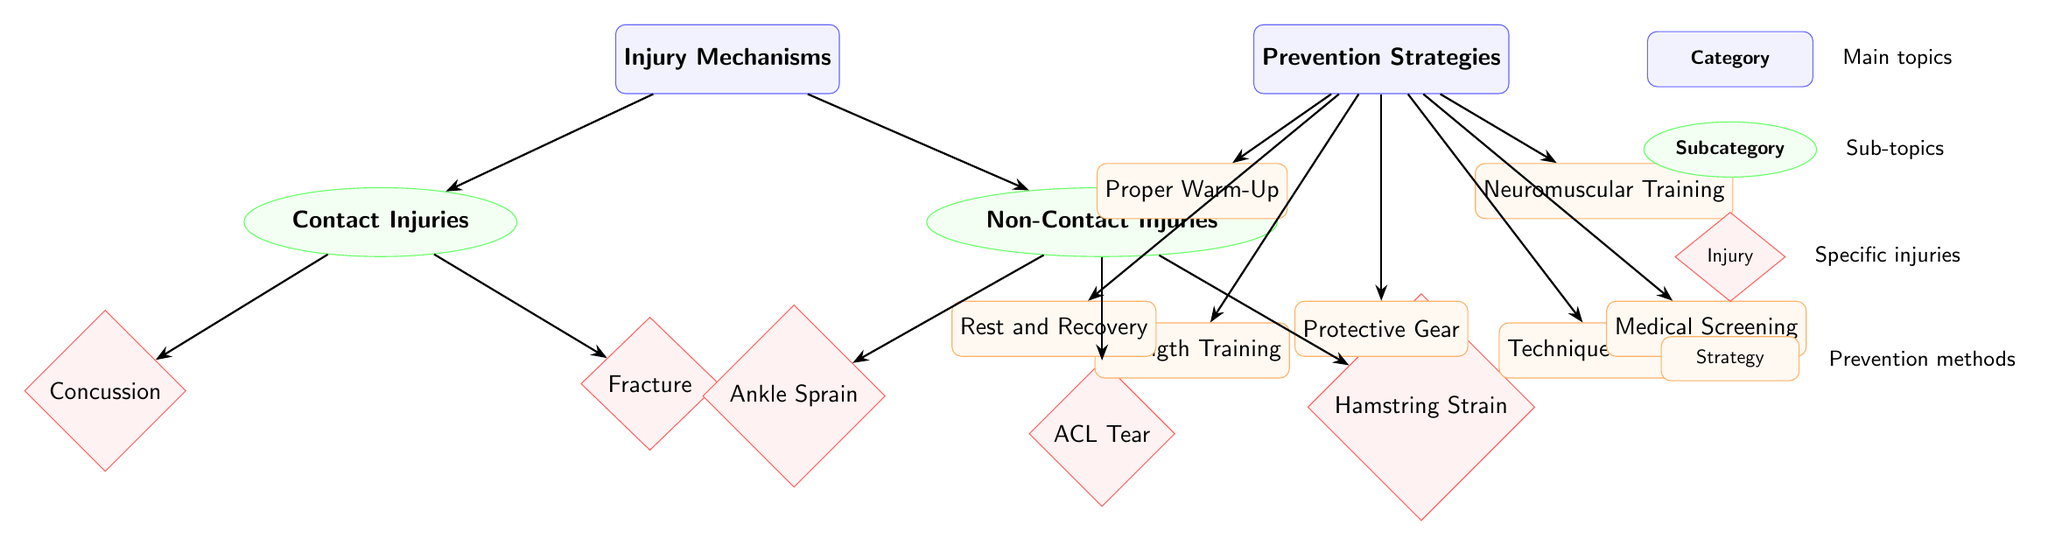What are the two categories of injury mechanisms? The diagram has a main category node labeled "Injury Mechanisms," which branches into two subcategories: "Contact Injuries" and "Non-Contact Injuries."
Answer: Contact Injuries, Non-Contact Injuries How many specific injuries are listed under Non-Contact Injuries? Under the "Non-Contact Injuries" node, there are three specific injuries listed: "Ankle Sprain," "ACL Tear," and "Hamstring Strain." Therefore, the count is three.
Answer: 3 What type of training is associated with reducing both contact and non-contact injuries? The diagram links several prevention strategies with the "Prevention Strategies" node. The "Neuromuscular Training" strategy is specifically positioned below the "Proper Warm-Up" and leads to injury prevention in both categories.
Answer: Neuromuscular Training Which prevention strategy focuses on recovery? Among the prevention strategies listed, "Rest and Recovery" is specifically mentioned, which aims at facilitating recovery from injuries. It is located left of "Protective Gear" in the prevention section.
Answer: Rest and Recovery Which category does "Fracture" fall under? In the diagram, "Fracture" is positioned under the "Contact Injuries" subcategory. It has a direct connection from the "Contact Injuries" node, indicating its classification.
Answer: Contact Injuries 